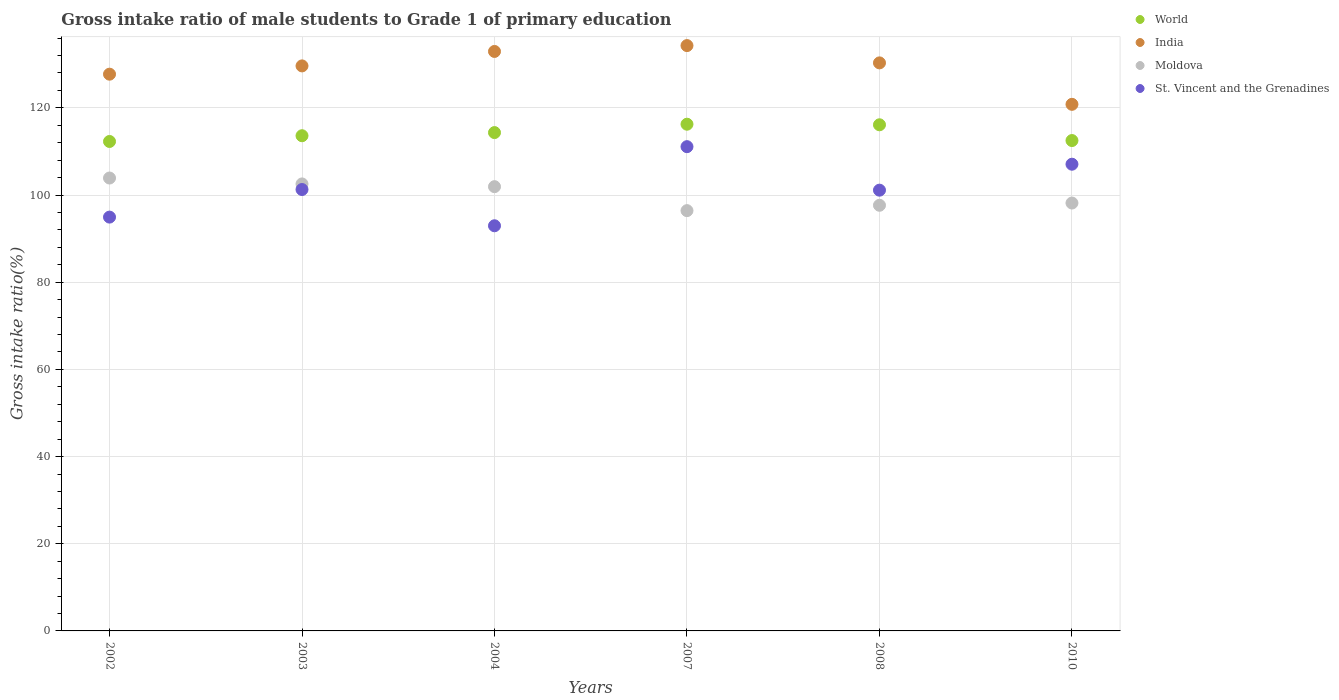What is the gross intake ratio in India in 2008?
Keep it short and to the point. 130.32. Across all years, what is the maximum gross intake ratio in World?
Your answer should be compact. 116.25. Across all years, what is the minimum gross intake ratio in World?
Make the answer very short. 112.29. What is the total gross intake ratio in Moldova in the graph?
Provide a short and direct response. 600.62. What is the difference between the gross intake ratio in Moldova in 2002 and that in 2003?
Ensure brevity in your answer.  1.36. What is the difference between the gross intake ratio in Moldova in 2002 and the gross intake ratio in St. Vincent and the Grenadines in 2010?
Keep it short and to the point. -3.17. What is the average gross intake ratio in World per year?
Ensure brevity in your answer.  114.18. In the year 2010, what is the difference between the gross intake ratio in Moldova and gross intake ratio in St. Vincent and the Grenadines?
Give a very brief answer. -8.91. In how many years, is the gross intake ratio in Moldova greater than 100 %?
Your answer should be compact. 3. What is the ratio of the gross intake ratio in World in 2004 to that in 2010?
Offer a very short reply. 1.02. Is the gross intake ratio in Moldova in 2004 less than that in 2010?
Ensure brevity in your answer.  No. Is the difference between the gross intake ratio in Moldova in 2002 and 2004 greater than the difference between the gross intake ratio in St. Vincent and the Grenadines in 2002 and 2004?
Offer a terse response. No. What is the difference between the highest and the second highest gross intake ratio in Moldova?
Your answer should be compact. 1.36. What is the difference between the highest and the lowest gross intake ratio in St. Vincent and the Grenadines?
Your response must be concise. 18.15. Does the gross intake ratio in World monotonically increase over the years?
Offer a terse response. No. Is the gross intake ratio in Moldova strictly less than the gross intake ratio in World over the years?
Your answer should be very brief. Yes. How many dotlines are there?
Offer a terse response. 4. How many years are there in the graph?
Ensure brevity in your answer.  6. Are the values on the major ticks of Y-axis written in scientific E-notation?
Your response must be concise. No. Where does the legend appear in the graph?
Your answer should be very brief. Top right. What is the title of the graph?
Offer a very short reply. Gross intake ratio of male students to Grade 1 of primary education. Does "Central Europe" appear as one of the legend labels in the graph?
Give a very brief answer. No. What is the label or title of the X-axis?
Your response must be concise. Years. What is the label or title of the Y-axis?
Give a very brief answer. Gross intake ratio(%). What is the Gross intake ratio(%) in World in 2002?
Provide a succinct answer. 112.29. What is the Gross intake ratio(%) in India in 2002?
Your answer should be very brief. 127.73. What is the Gross intake ratio(%) in Moldova in 2002?
Your answer should be compact. 103.9. What is the Gross intake ratio(%) in St. Vincent and the Grenadines in 2002?
Your response must be concise. 94.94. What is the Gross intake ratio(%) in World in 2003?
Your answer should be very brief. 113.61. What is the Gross intake ratio(%) in India in 2003?
Provide a succinct answer. 129.63. What is the Gross intake ratio(%) of Moldova in 2003?
Your answer should be compact. 102.55. What is the Gross intake ratio(%) in St. Vincent and the Grenadines in 2003?
Make the answer very short. 101.27. What is the Gross intake ratio(%) of World in 2004?
Make the answer very short. 114.33. What is the Gross intake ratio(%) of India in 2004?
Make the answer very short. 132.94. What is the Gross intake ratio(%) of Moldova in 2004?
Offer a very short reply. 101.92. What is the Gross intake ratio(%) in St. Vincent and the Grenadines in 2004?
Your answer should be very brief. 92.95. What is the Gross intake ratio(%) in World in 2007?
Your answer should be very brief. 116.25. What is the Gross intake ratio(%) of India in 2007?
Provide a succinct answer. 134.29. What is the Gross intake ratio(%) of Moldova in 2007?
Provide a succinct answer. 96.42. What is the Gross intake ratio(%) of St. Vincent and the Grenadines in 2007?
Your response must be concise. 111.1. What is the Gross intake ratio(%) in World in 2008?
Offer a terse response. 116.12. What is the Gross intake ratio(%) of India in 2008?
Provide a short and direct response. 130.32. What is the Gross intake ratio(%) of Moldova in 2008?
Make the answer very short. 97.65. What is the Gross intake ratio(%) of St. Vincent and the Grenadines in 2008?
Ensure brevity in your answer.  101.12. What is the Gross intake ratio(%) in World in 2010?
Your answer should be compact. 112.5. What is the Gross intake ratio(%) in India in 2010?
Keep it short and to the point. 120.81. What is the Gross intake ratio(%) of Moldova in 2010?
Your response must be concise. 98.17. What is the Gross intake ratio(%) of St. Vincent and the Grenadines in 2010?
Ensure brevity in your answer.  107.07. Across all years, what is the maximum Gross intake ratio(%) in World?
Your answer should be very brief. 116.25. Across all years, what is the maximum Gross intake ratio(%) of India?
Give a very brief answer. 134.29. Across all years, what is the maximum Gross intake ratio(%) of Moldova?
Ensure brevity in your answer.  103.9. Across all years, what is the maximum Gross intake ratio(%) of St. Vincent and the Grenadines?
Your answer should be very brief. 111.1. Across all years, what is the minimum Gross intake ratio(%) of World?
Offer a terse response. 112.29. Across all years, what is the minimum Gross intake ratio(%) of India?
Give a very brief answer. 120.81. Across all years, what is the minimum Gross intake ratio(%) of Moldova?
Your answer should be compact. 96.42. Across all years, what is the minimum Gross intake ratio(%) in St. Vincent and the Grenadines?
Make the answer very short. 92.95. What is the total Gross intake ratio(%) in World in the graph?
Your answer should be compact. 685.1. What is the total Gross intake ratio(%) in India in the graph?
Provide a succinct answer. 775.73. What is the total Gross intake ratio(%) of Moldova in the graph?
Your answer should be very brief. 600.62. What is the total Gross intake ratio(%) of St. Vincent and the Grenadines in the graph?
Provide a short and direct response. 608.45. What is the difference between the Gross intake ratio(%) in World in 2002 and that in 2003?
Provide a succinct answer. -1.32. What is the difference between the Gross intake ratio(%) in India in 2002 and that in 2003?
Your answer should be compact. -1.9. What is the difference between the Gross intake ratio(%) in Moldova in 2002 and that in 2003?
Offer a very short reply. 1.36. What is the difference between the Gross intake ratio(%) of St. Vincent and the Grenadines in 2002 and that in 2003?
Ensure brevity in your answer.  -6.33. What is the difference between the Gross intake ratio(%) of World in 2002 and that in 2004?
Provide a short and direct response. -2.04. What is the difference between the Gross intake ratio(%) in India in 2002 and that in 2004?
Your answer should be very brief. -5.22. What is the difference between the Gross intake ratio(%) of Moldova in 2002 and that in 2004?
Provide a succinct answer. 1.98. What is the difference between the Gross intake ratio(%) in St. Vincent and the Grenadines in 2002 and that in 2004?
Ensure brevity in your answer.  1.99. What is the difference between the Gross intake ratio(%) of World in 2002 and that in 2007?
Keep it short and to the point. -3.96. What is the difference between the Gross intake ratio(%) of India in 2002 and that in 2007?
Provide a short and direct response. -6.56. What is the difference between the Gross intake ratio(%) in Moldova in 2002 and that in 2007?
Offer a very short reply. 7.48. What is the difference between the Gross intake ratio(%) of St. Vincent and the Grenadines in 2002 and that in 2007?
Make the answer very short. -16.16. What is the difference between the Gross intake ratio(%) in World in 2002 and that in 2008?
Make the answer very short. -3.83. What is the difference between the Gross intake ratio(%) in India in 2002 and that in 2008?
Provide a succinct answer. -2.59. What is the difference between the Gross intake ratio(%) in Moldova in 2002 and that in 2008?
Keep it short and to the point. 6.25. What is the difference between the Gross intake ratio(%) of St. Vincent and the Grenadines in 2002 and that in 2008?
Make the answer very short. -6.18. What is the difference between the Gross intake ratio(%) in World in 2002 and that in 2010?
Ensure brevity in your answer.  -0.21. What is the difference between the Gross intake ratio(%) in India in 2002 and that in 2010?
Provide a succinct answer. 6.92. What is the difference between the Gross intake ratio(%) of Moldova in 2002 and that in 2010?
Keep it short and to the point. 5.74. What is the difference between the Gross intake ratio(%) in St. Vincent and the Grenadines in 2002 and that in 2010?
Your answer should be compact. -12.14. What is the difference between the Gross intake ratio(%) in World in 2003 and that in 2004?
Offer a very short reply. -0.72. What is the difference between the Gross intake ratio(%) of India in 2003 and that in 2004?
Your response must be concise. -3.32. What is the difference between the Gross intake ratio(%) of Moldova in 2003 and that in 2004?
Make the answer very short. 0.63. What is the difference between the Gross intake ratio(%) of St. Vincent and the Grenadines in 2003 and that in 2004?
Offer a very short reply. 8.32. What is the difference between the Gross intake ratio(%) in World in 2003 and that in 2007?
Your answer should be compact. -2.64. What is the difference between the Gross intake ratio(%) in India in 2003 and that in 2007?
Your response must be concise. -4.66. What is the difference between the Gross intake ratio(%) of Moldova in 2003 and that in 2007?
Provide a short and direct response. 6.13. What is the difference between the Gross intake ratio(%) in St. Vincent and the Grenadines in 2003 and that in 2007?
Offer a very short reply. -9.83. What is the difference between the Gross intake ratio(%) of World in 2003 and that in 2008?
Give a very brief answer. -2.51. What is the difference between the Gross intake ratio(%) in India in 2003 and that in 2008?
Offer a very short reply. -0.69. What is the difference between the Gross intake ratio(%) of Moldova in 2003 and that in 2008?
Provide a short and direct response. 4.9. What is the difference between the Gross intake ratio(%) in St. Vincent and the Grenadines in 2003 and that in 2008?
Your answer should be very brief. 0.15. What is the difference between the Gross intake ratio(%) of World in 2003 and that in 2010?
Offer a terse response. 1.11. What is the difference between the Gross intake ratio(%) of India in 2003 and that in 2010?
Provide a short and direct response. 8.82. What is the difference between the Gross intake ratio(%) of Moldova in 2003 and that in 2010?
Provide a succinct answer. 4.38. What is the difference between the Gross intake ratio(%) in St. Vincent and the Grenadines in 2003 and that in 2010?
Keep it short and to the point. -5.81. What is the difference between the Gross intake ratio(%) of World in 2004 and that in 2007?
Your response must be concise. -1.92. What is the difference between the Gross intake ratio(%) of India in 2004 and that in 2007?
Make the answer very short. -1.34. What is the difference between the Gross intake ratio(%) of Moldova in 2004 and that in 2007?
Make the answer very short. 5.5. What is the difference between the Gross intake ratio(%) in St. Vincent and the Grenadines in 2004 and that in 2007?
Ensure brevity in your answer.  -18.15. What is the difference between the Gross intake ratio(%) in World in 2004 and that in 2008?
Provide a short and direct response. -1.79. What is the difference between the Gross intake ratio(%) in India in 2004 and that in 2008?
Make the answer very short. 2.62. What is the difference between the Gross intake ratio(%) of Moldova in 2004 and that in 2008?
Give a very brief answer. 4.27. What is the difference between the Gross intake ratio(%) of St. Vincent and the Grenadines in 2004 and that in 2008?
Make the answer very short. -8.17. What is the difference between the Gross intake ratio(%) in World in 2004 and that in 2010?
Provide a short and direct response. 1.83. What is the difference between the Gross intake ratio(%) in India in 2004 and that in 2010?
Give a very brief answer. 12.13. What is the difference between the Gross intake ratio(%) in Moldova in 2004 and that in 2010?
Provide a succinct answer. 3.75. What is the difference between the Gross intake ratio(%) of St. Vincent and the Grenadines in 2004 and that in 2010?
Your answer should be compact. -14.12. What is the difference between the Gross intake ratio(%) in World in 2007 and that in 2008?
Offer a terse response. 0.13. What is the difference between the Gross intake ratio(%) of India in 2007 and that in 2008?
Your answer should be very brief. 3.97. What is the difference between the Gross intake ratio(%) of Moldova in 2007 and that in 2008?
Provide a succinct answer. -1.23. What is the difference between the Gross intake ratio(%) in St. Vincent and the Grenadines in 2007 and that in 2008?
Ensure brevity in your answer.  9.98. What is the difference between the Gross intake ratio(%) in World in 2007 and that in 2010?
Keep it short and to the point. 3.75. What is the difference between the Gross intake ratio(%) in India in 2007 and that in 2010?
Make the answer very short. 13.48. What is the difference between the Gross intake ratio(%) of Moldova in 2007 and that in 2010?
Offer a very short reply. -1.75. What is the difference between the Gross intake ratio(%) of St. Vincent and the Grenadines in 2007 and that in 2010?
Your answer should be compact. 4.03. What is the difference between the Gross intake ratio(%) in World in 2008 and that in 2010?
Your answer should be very brief. 3.62. What is the difference between the Gross intake ratio(%) in India in 2008 and that in 2010?
Offer a very short reply. 9.51. What is the difference between the Gross intake ratio(%) of Moldova in 2008 and that in 2010?
Offer a terse response. -0.52. What is the difference between the Gross intake ratio(%) in St. Vincent and the Grenadines in 2008 and that in 2010?
Keep it short and to the point. -5.95. What is the difference between the Gross intake ratio(%) of World in 2002 and the Gross intake ratio(%) of India in 2003?
Your answer should be very brief. -17.34. What is the difference between the Gross intake ratio(%) of World in 2002 and the Gross intake ratio(%) of Moldova in 2003?
Ensure brevity in your answer.  9.74. What is the difference between the Gross intake ratio(%) in World in 2002 and the Gross intake ratio(%) in St. Vincent and the Grenadines in 2003?
Your answer should be very brief. 11.02. What is the difference between the Gross intake ratio(%) in India in 2002 and the Gross intake ratio(%) in Moldova in 2003?
Provide a succinct answer. 25.18. What is the difference between the Gross intake ratio(%) in India in 2002 and the Gross intake ratio(%) in St. Vincent and the Grenadines in 2003?
Your answer should be compact. 26.46. What is the difference between the Gross intake ratio(%) in Moldova in 2002 and the Gross intake ratio(%) in St. Vincent and the Grenadines in 2003?
Your answer should be compact. 2.64. What is the difference between the Gross intake ratio(%) of World in 2002 and the Gross intake ratio(%) of India in 2004?
Ensure brevity in your answer.  -20.65. What is the difference between the Gross intake ratio(%) in World in 2002 and the Gross intake ratio(%) in Moldova in 2004?
Ensure brevity in your answer.  10.37. What is the difference between the Gross intake ratio(%) of World in 2002 and the Gross intake ratio(%) of St. Vincent and the Grenadines in 2004?
Ensure brevity in your answer.  19.34. What is the difference between the Gross intake ratio(%) in India in 2002 and the Gross intake ratio(%) in Moldova in 2004?
Ensure brevity in your answer.  25.81. What is the difference between the Gross intake ratio(%) of India in 2002 and the Gross intake ratio(%) of St. Vincent and the Grenadines in 2004?
Offer a very short reply. 34.78. What is the difference between the Gross intake ratio(%) in Moldova in 2002 and the Gross intake ratio(%) in St. Vincent and the Grenadines in 2004?
Provide a succinct answer. 10.95. What is the difference between the Gross intake ratio(%) in World in 2002 and the Gross intake ratio(%) in India in 2007?
Give a very brief answer. -22. What is the difference between the Gross intake ratio(%) of World in 2002 and the Gross intake ratio(%) of Moldova in 2007?
Ensure brevity in your answer.  15.87. What is the difference between the Gross intake ratio(%) of World in 2002 and the Gross intake ratio(%) of St. Vincent and the Grenadines in 2007?
Make the answer very short. 1.19. What is the difference between the Gross intake ratio(%) in India in 2002 and the Gross intake ratio(%) in Moldova in 2007?
Give a very brief answer. 31.31. What is the difference between the Gross intake ratio(%) of India in 2002 and the Gross intake ratio(%) of St. Vincent and the Grenadines in 2007?
Offer a very short reply. 16.63. What is the difference between the Gross intake ratio(%) of Moldova in 2002 and the Gross intake ratio(%) of St. Vincent and the Grenadines in 2007?
Your response must be concise. -7.2. What is the difference between the Gross intake ratio(%) in World in 2002 and the Gross intake ratio(%) in India in 2008?
Your answer should be compact. -18.03. What is the difference between the Gross intake ratio(%) in World in 2002 and the Gross intake ratio(%) in Moldova in 2008?
Keep it short and to the point. 14.64. What is the difference between the Gross intake ratio(%) of World in 2002 and the Gross intake ratio(%) of St. Vincent and the Grenadines in 2008?
Keep it short and to the point. 11.17. What is the difference between the Gross intake ratio(%) in India in 2002 and the Gross intake ratio(%) in Moldova in 2008?
Provide a succinct answer. 30.08. What is the difference between the Gross intake ratio(%) of India in 2002 and the Gross intake ratio(%) of St. Vincent and the Grenadines in 2008?
Your answer should be compact. 26.61. What is the difference between the Gross intake ratio(%) of Moldova in 2002 and the Gross intake ratio(%) of St. Vincent and the Grenadines in 2008?
Keep it short and to the point. 2.79. What is the difference between the Gross intake ratio(%) of World in 2002 and the Gross intake ratio(%) of India in 2010?
Offer a very short reply. -8.52. What is the difference between the Gross intake ratio(%) of World in 2002 and the Gross intake ratio(%) of Moldova in 2010?
Ensure brevity in your answer.  14.12. What is the difference between the Gross intake ratio(%) of World in 2002 and the Gross intake ratio(%) of St. Vincent and the Grenadines in 2010?
Your response must be concise. 5.22. What is the difference between the Gross intake ratio(%) of India in 2002 and the Gross intake ratio(%) of Moldova in 2010?
Keep it short and to the point. 29.56. What is the difference between the Gross intake ratio(%) of India in 2002 and the Gross intake ratio(%) of St. Vincent and the Grenadines in 2010?
Offer a terse response. 20.66. What is the difference between the Gross intake ratio(%) in Moldova in 2002 and the Gross intake ratio(%) in St. Vincent and the Grenadines in 2010?
Keep it short and to the point. -3.17. What is the difference between the Gross intake ratio(%) of World in 2003 and the Gross intake ratio(%) of India in 2004?
Ensure brevity in your answer.  -19.34. What is the difference between the Gross intake ratio(%) in World in 2003 and the Gross intake ratio(%) in Moldova in 2004?
Make the answer very short. 11.69. What is the difference between the Gross intake ratio(%) of World in 2003 and the Gross intake ratio(%) of St. Vincent and the Grenadines in 2004?
Provide a succinct answer. 20.66. What is the difference between the Gross intake ratio(%) in India in 2003 and the Gross intake ratio(%) in Moldova in 2004?
Make the answer very short. 27.71. What is the difference between the Gross intake ratio(%) in India in 2003 and the Gross intake ratio(%) in St. Vincent and the Grenadines in 2004?
Ensure brevity in your answer.  36.68. What is the difference between the Gross intake ratio(%) of Moldova in 2003 and the Gross intake ratio(%) of St. Vincent and the Grenadines in 2004?
Offer a very short reply. 9.6. What is the difference between the Gross intake ratio(%) in World in 2003 and the Gross intake ratio(%) in India in 2007?
Ensure brevity in your answer.  -20.68. What is the difference between the Gross intake ratio(%) in World in 2003 and the Gross intake ratio(%) in Moldova in 2007?
Your answer should be compact. 17.18. What is the difference between the Gross intake ratio(%) of World in 2003 and the Gross intake ratio(%) of St. Vincent and the Grenadines in 2007?
Make the answer very short. 2.51. What is the difference between the Gross intake ratio(%) of India in 2003 and the Gross intake ratio(%) of Moldova in 2007?
Give a very brief answer. 33.21. What is the difference between the Gross intake ratio(%) in India in 2003 and the Gross intake ratio(%) in St. Vincent and the Grenadines in 2007?
Offer a very short reply. 18.53. What is the difference between the Gross intake ratio(%) of Moldova in 2003 and the Gross intake ratio(%) of St. Vincent and the Grenadines in 2007?
Provide a short and direct response. -8.55. What is the difference between the Gross intake ratio(%) in World in 2003 and the Gross intake ratio(%) in India in 2008?
Ensure brevity in your answer.  -16.71. What is the difference between the Gross intake ratio(%) in World in 2003 and the Gross intake ratio(%) in Moldova in 2008?
Your answer should be very brief. 15.96. What is the difference between the Gross intake ratio(%) of World in 2003 and the Gross intake ratio(%) of St. Vincent and the Grenadines in 2008?
Your answer should be compact. 12.49. What is the difference between the Gross intake ratio(%) in India in 2003 and the Gross intake ratio(%) in Moldova in 2008?
Offer a very short reply. 31.98. What is the difference between the Gross intake ratio(%) in India in 2003 and the Gross intake ratio(%) in St. Vincent and the Grenadines in 2008?
Offer a terse response. 28.51. What is the difference between the Gross intake ratio(%) in Moldova in 2003 and the Gross intake ratio(%) in St. Vincent and the Grenadines in 2008?
Give a very brief answer. 1.43. What is the difference between the Gross intake ratio(%) in World in 2003 and the Gross intake ratio(%) in India in 2010?
Make the answer very short. -7.2. What is the difference between the Gross intake ratio(%) of World in 2003 and the Gross intake ratio(%) of Moldova in 2010?
Offer a terse response. 15.44. What is the difference between the Gross intake ratio(%) of World in 2003 and the Gross intake ratio(%) of St. Vincent and the Grenadines in 2010?
Provide a succinct answer. 6.53. What is the difference between the Gross intake ratio(%) in India in 2003 and the Gross intake ratio(%) in Moldova in 2010?
Your response must be concise. 31.46. What is the difference between the Gross intake ratio(%) of India in 2003 and the Gross intake ratio(%) of St. Vincent and the Grenadines in 2010?
Your answer should be compact. 22.55. What is the difference between the Gross intake ratio(%) of Moldova in 2003 and the Gross intake ratio(%) of St. Vincent and the Grenadines in 2010?
Make the answer very short. -4.52. What is the difference between the Gross intake ratio(%) in World in 2004 and the Gross intake ratio(%) in India in 2007?
Your answer should be compact. -19.96. What is the difference between the Gross intake ratio(%) of World in 2004 and the Gross intake ratio(%) of Moldova in 2007?
Give a very brief answer. 17.91. What is the difference between the Gross intake ratio(%) of World in 2004 and the Gross intake ratio(%) of St. Vincent and the Grenadines in 2007?
Offer a very short reply. 3.23. What is the difference between the Gross intake ratio(%) of India in 2004 and the Gross intake ratio(%) of Moldova in 2007?
Provide a succinct answer. 36.52. What is the difference between the Gross intake ratio(%) of India in 2004 and the Gross intake ratio(%) of St. Vincent and the Grenadines in 2007?
Offer a very short reply. 21.84. What is the difference between the Gross intake ratio(%) of Moldova in 2004 and the Gross intake ratio(%) of St. Vincent and the Grenadines in 2007?
Give a very brief answer. -9.18. What is the difference between the Gross intake ratio(%) of World in 2004 and the Gross intake ratio(%) of India in 2008?
Keep it short and to the point. -15.99. What is the difference between the Gross intake ratio(%) in World in 2004 and the Gross intake ratio(%) in Moldova in 2008?
Give a very brief answer. 16.68. What is the difference between the Gross intake ratio(%) of World in 2004 and the Gross intake ratio(%) of St. Vincent and the Grenadines in 2008?
Ensure brevity in your answer.  13.21. What is the difference between the Gross intake ratio(%) of India in 2004 and the Gross intake ratio(%) of Moldova in 2008?
Your answer should be compact. 35.29. What is the difference between the Gross intake ratio(%) of India in 2004 and the Gross intake ratio(%) of St. Vincent and the Grenadines in 2008?
Your answer should be very brief. 31.83. What is the difference between the Gross intake ratio(%) in Moldova in 2004 and the Gross intake ratio(%) in St. Vincent and the Grenadines in 2008?
Your response must be concise. 0.8. What is the difference between the Gross intake ratio(%) in World in 2004 and the Gross intake ratio(%) in India in 2010?
Ensure brevity in your answer.  -6.48. What is the difference between the Gross intake ratio(%) of World in 2004 and the Gross intake ratio(%) of Moldova in 2010?
Offer a very short reply. 16.16. What is the difference between the Gross intake ratio(%) of World in 2004 and the Gross intake ratio(%) of St. Vincent and the Grenadines in 2010?
Give a very brief answer. 7.25. What is the difference between the Gross intake ratio(%) in India in 2004 and the Gross intake ratio(%) in Moldova in 2010?
Give a very brief answer. 34.78. What is the difference between the Gross intake ratio(%) in India in 2004 and the Gross intake ratio(%) in St. Vincent and the Grenadines in 2010?
Keep it short and to the point. 25.87. What is the difference between the Gross intake ratio(%) in Moldova in 2004 and the Gross intake ratio(%) in St. Vincent and the Grenadines in 2010?
Provide a short and direct response. -5.15. What is the difference between the Gross intake ratio(%) of World in 2007 and the Gross intake ratio(%) of India in 2008?
Your answer should be compact. -14.07. What is the difference between the Gross intake ratio(%) of World in 2007 and the Gross intake ratio(%) of Moldova in 2008?
Offer a very short reply. 18.6. What is the difference between the Gross intake ratio(%) in World in 2007 and the Gross intake ratio(%) in St. Vincent and the Grenadines in 2008?
Provide a short and direct response. 15.13. What is the difference between the Gross intake ratio(%) of India in 2007 and the Gross intake ratio(%) of Moldova in 2008?
Ensure brevity in your answer.  36.64. What is the difference between the Gross intake ratio(%) in India in 2007 and the Gross intake ratio(%) in St. Vincent and the Grenadines in 2008?
Keep it short and to the point. 33.17. What is the difference between the Gross intake ratio(%) of Moldova in 2007 and the Gross intake ratio(%) of St. Vincent and the Grenadines in 2008?
Offer a very short reply. -4.7. What is the difference between the Gross intake ratio(%) in World in 2007 and the Gross intake ratio(%) in India in 2010?
Offer a very short reply. -4.56. What is the difference between the Gross intake ratio(%) of World in 2007 and the Gross intake ratio(%) of Moldova in 2010?
Ensure brevity in your answer.  18.08. What is the difference between the Gross intake ratio(%) of World in 2007 and the Gross intake ratio(%) of St. Vincent and the Grenadines in 2010?
Offer a very short reply. 9.18. What is the difference between the Gross intake ratio(%) of India in 2007 and the Gross intake ratio(%) of Moldova in 2010?
Offer a terse response. 36.12. What is the difference between the Gross intake ratio(%) of India in 2007 and the Gross intake ratio(%) of St. Vincent and the Grenadines in 2010?
Provide a short and direct response. 27.22. What is the difference between the Gross intake ratio(%) of Moldova in 2007 and the Gross intake ratio(%) of St. Vincent and the Grenadines in 2010?
Offer a very short reply. -10.65. What is the difference between the Gross intake ratio(%) of World in 2008 and the Gross intake ratio(%) of India in 2010?
Give a very brief answer. -4.69. What is the difference between the Gross intake ratio(%) of World in 2008 and the Gross intake ratio(%) of Moldova in 2010?
Make the answer very short. 17.95. What is the difference between the Gross intake ratio(%) in World in 2008 and the Gross intake ratio(%) in St. Vincent and the Grenadines in 2010?
Ensure brevity in your answer.  9.04. What is the difference between the Gross intake ratio(%) of India in 2008 and the Gross intake ratio(%) of Moldova in 2010?
Offer a terse response. 32.15. What is the difference between the Gross intake ratio(%) in India in 2008 and the Gross intake ratio(%) in St. Vincent and the Grenadines in 2010?
Give a very brief answer. 23.25. What is the difference between the Gross intake ratio(%) of Moldova in 2008 and the Gross intake ratio(%) of St. Vincent and the Grenadines in 2010?
Your answer should be compact. -9.42. What is the average Gross intake ratio(%) of World per year?
Keep it short and to the point. 114.18. What is the average Gross intake ratio(%) of India per year?
Your response must be concise. 129.29. What is the average Gross intake ratio(%) in Moldova per year?
Make the answer very short. 100.1. What is the average Gross intake ratio(%) in St. Vincent and the Grenadines per year?
Give a very brief answer. 101.41. In the year 2002, what is the difference between the Gross intake ratio(%) in World and Gross intake ratio(%) in India?
Your answer should be compact. -15.44. In the year 2002, what is the difference between the Gross intake ratio(%) of World and Gross intake ratio(%) of Moldova?
Offer a very short reply. 8.39. In the year 2002, what is the difference between the Gross intake ratio(%) of World and Gross intake ratio(%) of St. Vincent and the Grenadines?
Offer a terse response. 17.35. In the year 2002, what is the difference between the Gross intake ratio(%) in India and Gross intake ratio(%) in Moldova?
Offer a terse response. 23.82. In the year 2002, what is the difference between the Gross intake ratio(%) in India and Gross intake ratio(%) in St. Vincent and the Grenadines?
Keep it short and to the point. 32.79. In the year 2002, what is the difference between the Gross intake ratio(%) of Moldova and Gross intake ratio(%) of St. Vincent and the Grenadines?
Your answer should be very brief. 8.97. In the year 2003, what is the difference between the Gross intake ratio(%) of World and Gross intake ratio(%) of India?
Your answer should be very brief. -16.02. In the year 2003, what is the difference between the Gross intake ratio(%) in World and Gross intake ratio(%) in Moldova?
Make the answer very short. 11.06. In the year 2003, what is the difference between the Gross intake ratio(%) in World and Gross intake ratio(%) in St. Vincent and the Grenadines?
Your answer should be very brief. 12.34. In the year 2003, what is the difference between the Gross intake ratio(%) in India and Gross intake ratio(%) in Moldova?
Your answer should be very brief. 27.08. In the year 2003, what is the difference between the Gross intake ratio(%) of India and Gross intake ratio(%) of St. Vincent and the Grenadines?
Keep it short and to the point. 28.36. In the year 2003, what is the difference between the Gross intake ratio(%) of Moldova and Gross intake ratio(%) of St. Vincent and the Grenadines?
Your answer should be very brief. 1.28. In the year 2004, what is the difference between the Gross intake ratio(%) in World and Gross intake ratio(%) in India?
Give a very brief answer. -18.62. In the year 2004, what is the difference between the Gross intake ratio(%) in World and Gross intake ratio(%) in Moldova?
Provide a short and direct response. 12.41. In the year 2004, what is the difference between the Gross intake ratio(%) in World and Gross intake ratio(%) in St. Vincent and the Grenadines?
Ensure brevity in your answer.  21.38. In the year 2004, what is the difference between the Gross intake ratio(%) of India and Gross intake ratio(%) of Moldova?
Give a very brief answer. 31.02. In the year 2004, what is the difference between the Gross intake ratio(%) in India and Gross intake ratio(%) in St. Vincent and the Grenadines?
Your response must be concise. 40. In the year 2004, what is the difference between the Gross intake ratio(%) in Moldova and Gross intake ratio(%) in St. Vincent and the Grenadines?
Provide a succinct answer. 8.97. In the year 2007, what is the difference between the Gross intake ratio(%) in World and Gross intake ratio(%) in India?
Give a very brief answer. -18.04. In the year 2007, what is the difference between the Gross intake ratio(%) of World and Gross intake ratio(%) of Moldova?
Keep it short and to the point. 19.83. In the year 2007, what is the difference between the Gross intake ratio(%) of World and Gross intake ratio(%) of St. Vincent and the Grenadines?
Offer a very short reply. 5.15. In the year 2007, what is the difference between the Gross intake ratio(%) in India and Gross intake ratio(%) in Moldova?
Provide a short and direct response. 37.87. In the year 2007, what is the difference between the Gross intake ratio(%) in India and Gross intake ratio(%) in St. Vincent and the Grenadines?
Your answer should be compact. 23.19. In the year 2007, what is the difference between the Gross intake ratio(%) in Moldova and Gross intake ratio(%) in St. Vincent and the Grenadines?
Offer a terse response. -14.68. In the year 2008, what is the difference between the Gross intake ratio(%) in World and Gross intake ratio(%) in India?
Your answer should be very brief. -14.2. In the year 2008, what is the difference between the Gross intake ratio(%) in World and Gross intake ratio(%) in Moldova?
Make the answer very short. 18.47. In the year 2008, what is the difference between the Gross intake ratio(%) of World and Gross intake ratio(%) of St. Vincent and the Grenadines?
Provide a short and direct response. 15. In the year 2008, what is the difference between the Gross intake ratio(%) in India and Gross intake ratio(%) in Moldova?
Provide a succinct answer. 32.67. In the year 2008, what is the difference between the Gross intake ratio(%) of India and Gross intake ratio(%) of St. Vincent and the Grenadines?
Your answer should be very brief. 29.2. In the year 2008, what is the difference between the Gross intake ratio(%) in Moldova and Gross intake ratio(%) in St. Vincent and the Grenadines?
Your response must be concise. -3.47. In the year 2010, what is the difference between the Gross intake ratio(%) of World and Gross intake ratio(%) of India?
Offer a very short reply. -8.31. In the year 2010, what is the difference between the Gross intake ratio(%) in World and Gross intake ratio(%) in Moldova?
Provide a succinct answer. 14.33. In the year 2010, what is the difference between the Gross intake ratio(%) of World and Gross intake ratio(%) of St. Vincent and the Grenadines?
Your answer should be very brief. 5.43. In the year 2010, what is the difference between the Gross intake ratio(%) of India and Gross intake ratio(%) of Moldova?
Your response must be concise. 22.64. In the year 2010, what is the difference between the Gross intake ratio(%) of India and Gross intake ratio(%) of St. Vincent and the Grenadines?
Make the answer very short. 13.74. In the year 2010, what is the difference between the Gross intake ratio(%) of Moldova and Gross intake ratio(%) of St. Vincent and the Grenadines?
Ensure brevity in your answer.  -8.91. What is the ratio of the Gross intake ratio(%) in World in 2002 to that in 2003?
Keep it short and to the point. 0.99. What is the ratio of the Gross intake ratio(%) of India in 2002 to that in 2003?
Your answer should be very brief. 0.99. What is the ratio of the Gross intake ratio(%) of Moldova in 2002 to that in 2003?
Your answer should be compact. 1.01. What is the ratio of the Gross intake ratio(%) in St. Vincent and the Grenadines in 2002 to that in 2003?
Your response must be concise. 0.94. What is the ratio of the Gross intake ratio(%) of World in 2002 to that in 2004?
Provide a short and direct response. 0.98. What is the ratio of the Gross intake ratio(%) of India in 2002 to that in 2004?
Make the answer very short. 0.96. What is the ratio of the Gross intake ratio(%) in Moldova in 2002 to that in 2004?
Provide a short and direct response. 1.02. What is the ratio of the Gross intake ratio(%) of St. Vincent and the Grenadines in 2002 to that in 2004?
Ensure brevity in your answer.  1.02. What is the ratio of the Gross intake ratio(%) of World in 2002 to that in 2007?
Offer a terse response. 0.97. What is the ratio of the Gross intake ratio(%) in India in 2002 to that in 2007?
Make the answer very short. 0.95. What is the ratio of the Gross intake ratio(%) of Moldova in 2002 to that in 2007?
Ensure brevity in your answer.  1.08. What is the ratio of the Gross intake ratio(%) in St. Vincent and the Grenadines in 2002 to that in 2007?
Keep it short and to the point. 0.85. What is the ratio of the Gross intake ratio(%) in World in 2002 to that in 2008?
Give a very brief answer. 0.97. What is the ratio of the Gross intake ratio(%) of India in 2002 to that in 2008?
Provide a succinct answer. 0.98. What is the ratio of the Gross intake ratio(%) of Moldova in 2002 to that in 2008?
Offer a very short reply. 1.06. What is the ratio of the Gross intake ratio(%) in St. Vincent and the Grenadines in 2002 to that in 2008?
Your response must be concise. 0.94. What is the ratio of the Gross intake ratio(%) of World in 2002 to that in 2010?
Give a very brief answer. 1. What is the ratio of the Gross intake ratio(%) of India in 2002 to that in 2010?
Offer a very short reply. 1.06. What is the ratio of the Gross intake ratio(%) in Moldova in 2002 to that in 2010?
Give a very brief answer. 1.06. What is the ratio of the Gross intake ratio(%) of St. Vincent and the Grenadines in 2002 to that in 2010?
Offer a terse response. 0.89. What is the ratio of the Gross intake ratio(%) in India in 2003 to that in 2004?
Keep it short and to the point. 0.97. What is the ratio of the Gross intake ratio(%) of Moldova in 2003 to that in 2004?
Your answer should be very brief. 1.01. What is the ratio of the Gross intake ratio(%) in St. Vincent and the Grenadines in 2003 to that in 2004?
Keep it short and to the point. 1.09. What is the ratio of the Gross intake ratio(%) in World in 2003 to that in 2007?
Provide a short and direct response. 0.98. What is the ratio of the Gross intake ratio(%) in India in 2003 to that in 2007?
Your response must be concise. 0.97. What is the ratio of the Gross intake ratio(%) of Moldova in 2003 to that in 2007?
Your answer should be very brief. 1.06. What is the ratio of the Gross intake ratio(%) in St. Vincent and the Grenadines in 2003 to that in 2007?
Your answer should be very brief. 0.91. What is the ratio of the Gross intake ratio(%) of World in 2003 to that in 2008?
Offer a terse response. 0.98. What is the ratio of the Gross intake ratio(%) in Moldova in 2003 to that in 2008?
Make the answer very short. 1.05. What is the ratio of the Gross intake ratio(%) in St. Vincent and the Grenadines in 2003 to that in 2008?
Your answer should be compact. 1. What is the ratio of the Gross intake ratio(%) in World in 2003 to that in 2010?
Your answer should be very brief. 1.01. What is the ratio of the Gross intake ratio(%) of India in 2003 to that in 2010?
Ensure brevity in your answer.  1.07. What is the ratio of the Gross intake ratio(%) in Moldova in 2003 to that in 2010?
Offer a very short reply. 1.04. What is the ratio of the Gross intake ratio(%) in St. Vincent and the Grenadines in 2003 to that in 2010?
Your answer should be very brief. 0.95. What is the ratio of the Gross intake ratio(%) in World in 2004 to that in 2007?
Your answer should be very brief. 0.98. What is the ratio of the Gross intake ratio(%) of Moldova in 2004 to that in 2007?
Give a very brief answer. 1.06. What is the ratio of the Gross intake ratio(%) of St. Vincent and the Grenadines in 2004 to that in 2007?
Offer a very short reply. 0.84. What is the ratio of the Gross intake ratio(%) of World in 2004 to that in 2008?
Provide a succinct answer. 0.98. What is the ratio of the Gross intake ratio(%) in India in 2004 to that in 2008?
Ensure brevity in your answer.  1.02. What is the ratio of the Gross intake ratio(%) of Moldova in 2004 to that in 2008?
Provide a short and direct response. 1.04. What is the ratio of the Gross intake ratio(%) of St. Vincent and the Grenadines in 2004 to that in 2008?
Your answer should be very brief. 0.92. What is the ratio of the Gross intake ratio(%) of World in 2004 to that in 2010?
Offer a terse response. 1.02. What is the ratio of the Gross intake ratio(%) in India in 2004 to that in 2010?
Ensure brevity in your answer.  1.1. What is the ratio of the Gross intake ratio(%) of Moldova in 2004 to that in 2010?
Keep it short and to the point. 1.04. What is the ratio of the Gross intake ratio(%) of St. Vincent and the Grenadines in 2004 to that in 2010?
Provide a succinct answer. 0.87. What is the ratio of the Gross intake ratio(%) in India in 2007 to that in 2008?
Give a very brief answer. 1.03. What is the ratio of the Gross intake ratio(%) of Moldova in 2007 to that in 2008?
Ensure brevity in your answer.  0.99. What is the ratio of the Gross intake ratio(%) of St. Vincent and the Grenadines in 2007 to that in 2008?
Your answer should be very brief. 1.1. What is the ratio of the Gross intake ratio(%) in World in 2007 to that in 2010?
Give a very brief answer. 1.03. What is the ratio of the Gross intake ratio(%) in India in 2007 to that in 2010?
Give a very brief answer. 1.11. What is the ratio of the Gross intake ratio(%) in Moldova in 2007 to that in 2010?
Your response must be concise. 0.98. What is the ratio of the Gross intake ratio(%) in St. Vincent and the Grenadines in 2007 to that in 2010?
Give a very brief answer. 1.04. What is the ratio of the Gross intake ratio(%) of World in 2008 to that in 2010?
Give a very brief answer. 1.03. What is the ratio of the Gross intake ratio(%) of India in 2008 to that in 2010?
Ensure brevity in your answer.  1.08. What is the ratio of the Gross intake ratio(%) in Moldova in 2008 to that in 2010?
Keep it short and to the point. 0.99. What is the ratio of the Gross intake ratio(%) of St. Vincent and the Grenadines in 2008 to that in 2010?
Offer a very short reply. 0.94. What is the difference between the highest and the second highest Gross intake ratio(%) of World?
Give a very brief answer. 0.13. What is the difference between the highest and the second highest Gross intake ratio(%) in India?
Keep it short and to the point. 1.34. What is the difference between the highest and the second highest Gross intake ratio(%) in Moldova?
Provide a short and direct response. 1.36. What is the difference between the highest and the second highest Gross intake ratio(%) in St. Vincent and the Grenadines?
Your response must be concise. 4.03. What is the difference between the highest and the lowest Gross intake ratio(%) of World?
Your answer should be compact. 3.96. What is the difference between the highest and the lowest Gross intake ratio(%) in India?
Keep it short and to the point. 13.48. What is the difference between the highest and the lowest Gross intake ratio(%) of Moldova?
Offer a terse response. 7.48. What is the difference between the highest and the lowest Gross intake ratio(%) of St. Vincent and the Grenadines?
Ensure brevity in your answer.  18.15. 